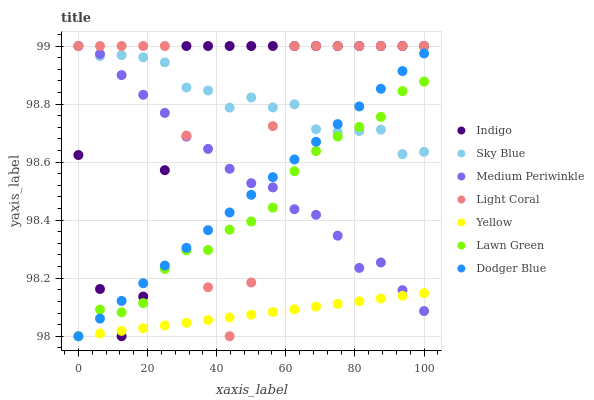Does Yellow have the minimum area under the curve?
Answer yes or no. Yes. Does Sky Blue have the maximum area under the curve?
Answer yes or no. Yes. Does Indigo have the minimum area under the curve?
Answer yes or no. No. Does Indigo have the maximum area under the curve?
Answer yes or no. No. Is Dodger Blue the smoothest?
Answer yes or no. Yes. Is Light Coral the roughest?
Answer yes or no. Yes. Is Indigo the smoothest?
Answer yes or no. No. Is Indigo the roughest?
Answer yes or no. No. Does Lawn Green have the lowest value?
Answer yes or no. Yes. Does Indigo have the lowest value?
Answer yes or no. No. Does Sky Blue have the highest value?
Answer yes or no. Yes. Does Yellow have the highest value?
Answer yes or no. No. Is Yellow less than Sky Blue?
Answer yes or no. Yes. Is Sky Blue greater than Yellow?
Answer yes or no. Yes. Does Lawn Green intersect Sky Blue?
Answer yes or no. Yes. Is Lawn Green less than Sky Blue?
Answer yes or no. No. Is Lawn Green greater than Sky Blue?
Answer yes or no. No. Does Yellow intersect Sky Blue?
Answer yes or no. No. 